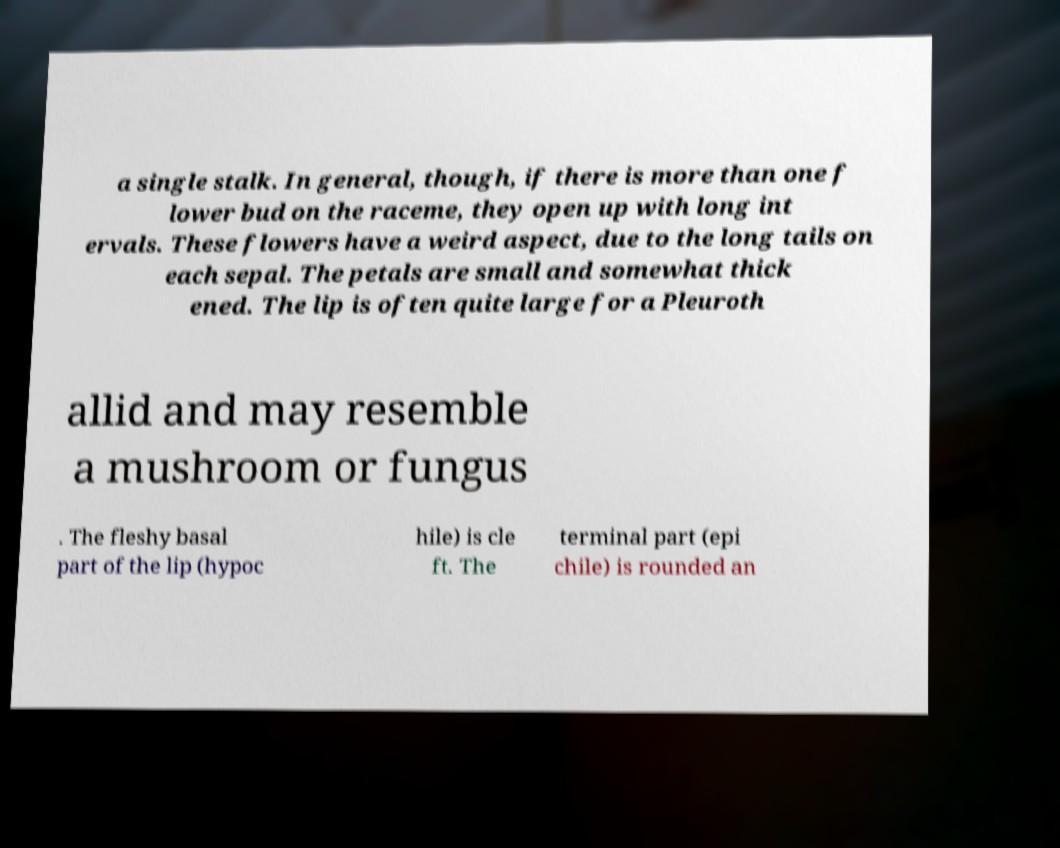Could you assist in decoding the text presented in this image and type it out clearly? a single stalk. In general, though, if there is more than one f lower bud on the raceme, they open up with long int ervals. These flowers have a weird aspect, due to the long tails on each sepal. The petals are small and somewhat thick ened. The lip is often quite large for a Pleuroth allid and may resemble a mushroom or fungus . The fleshy basal part of the lip (hypoc hile) is cle ft. The terminal part (epi chile) is rounded an 